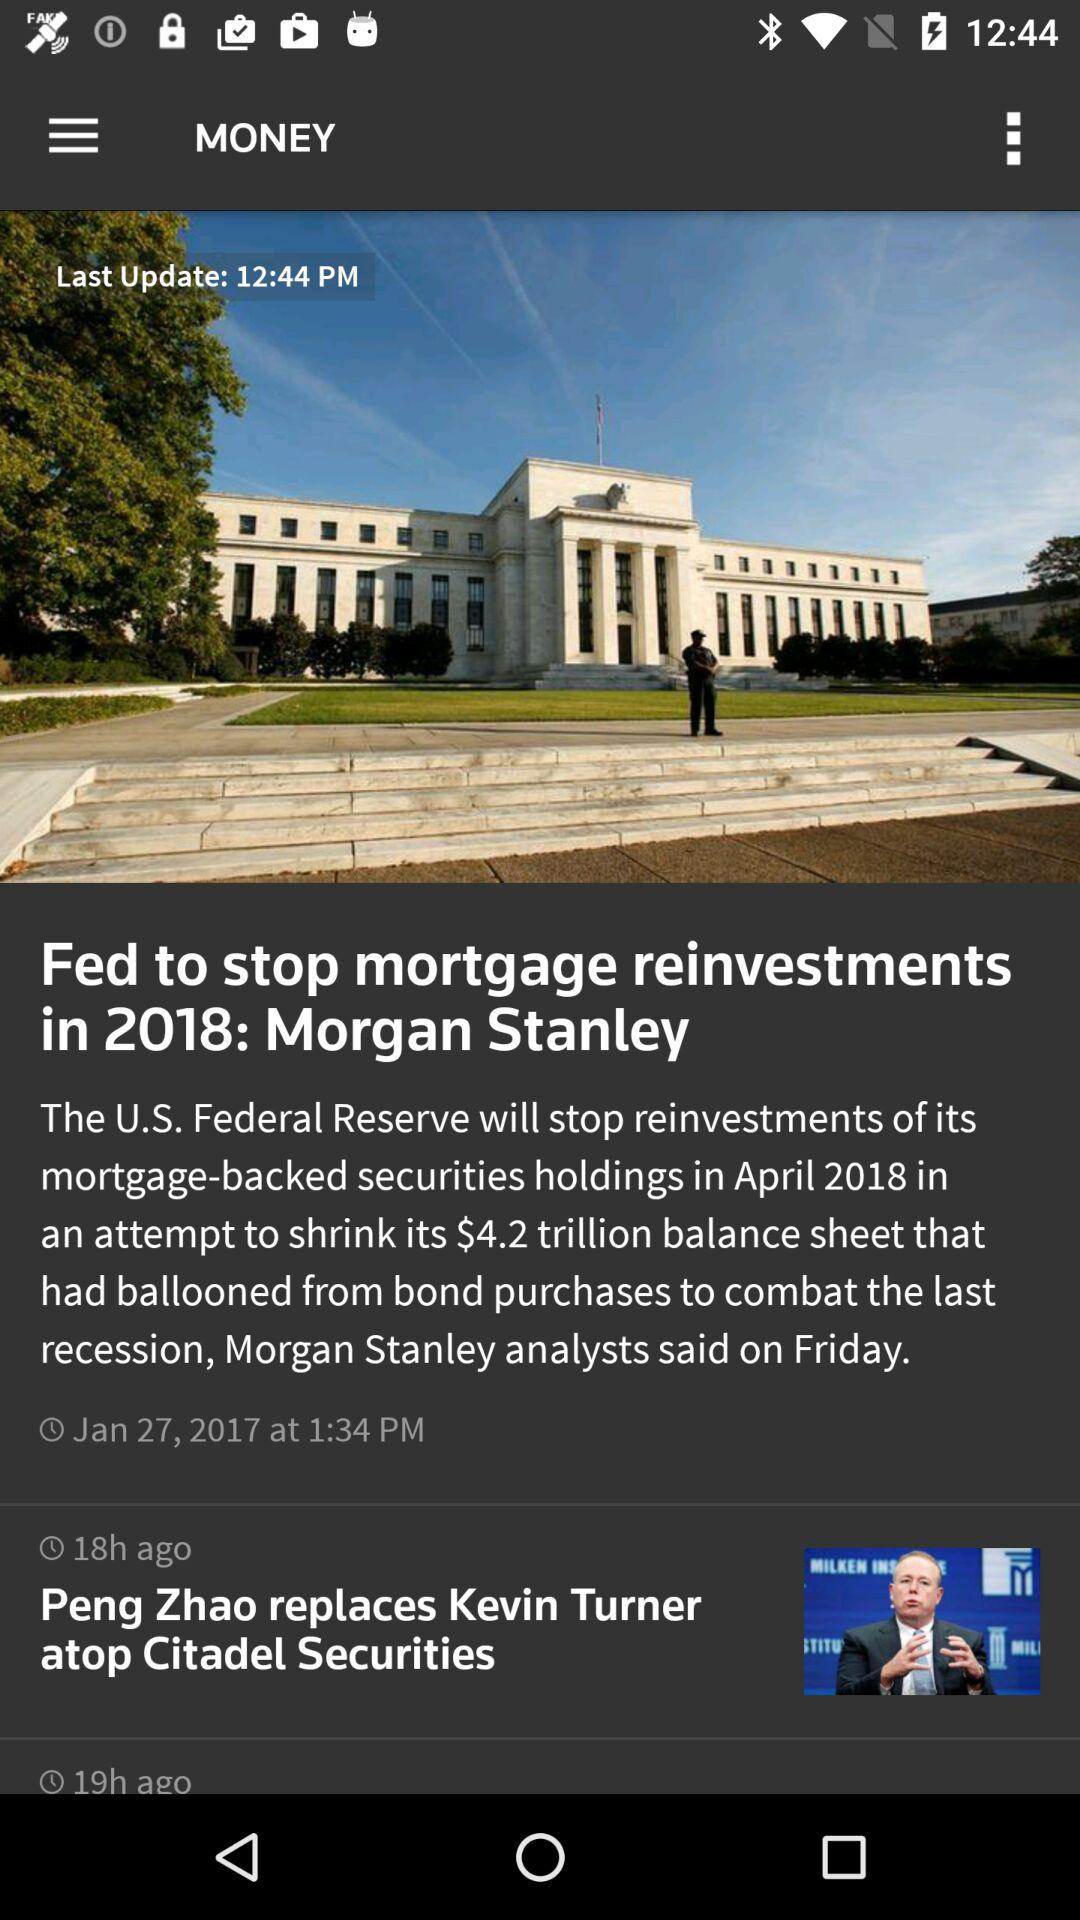What is the month? The month is January. 